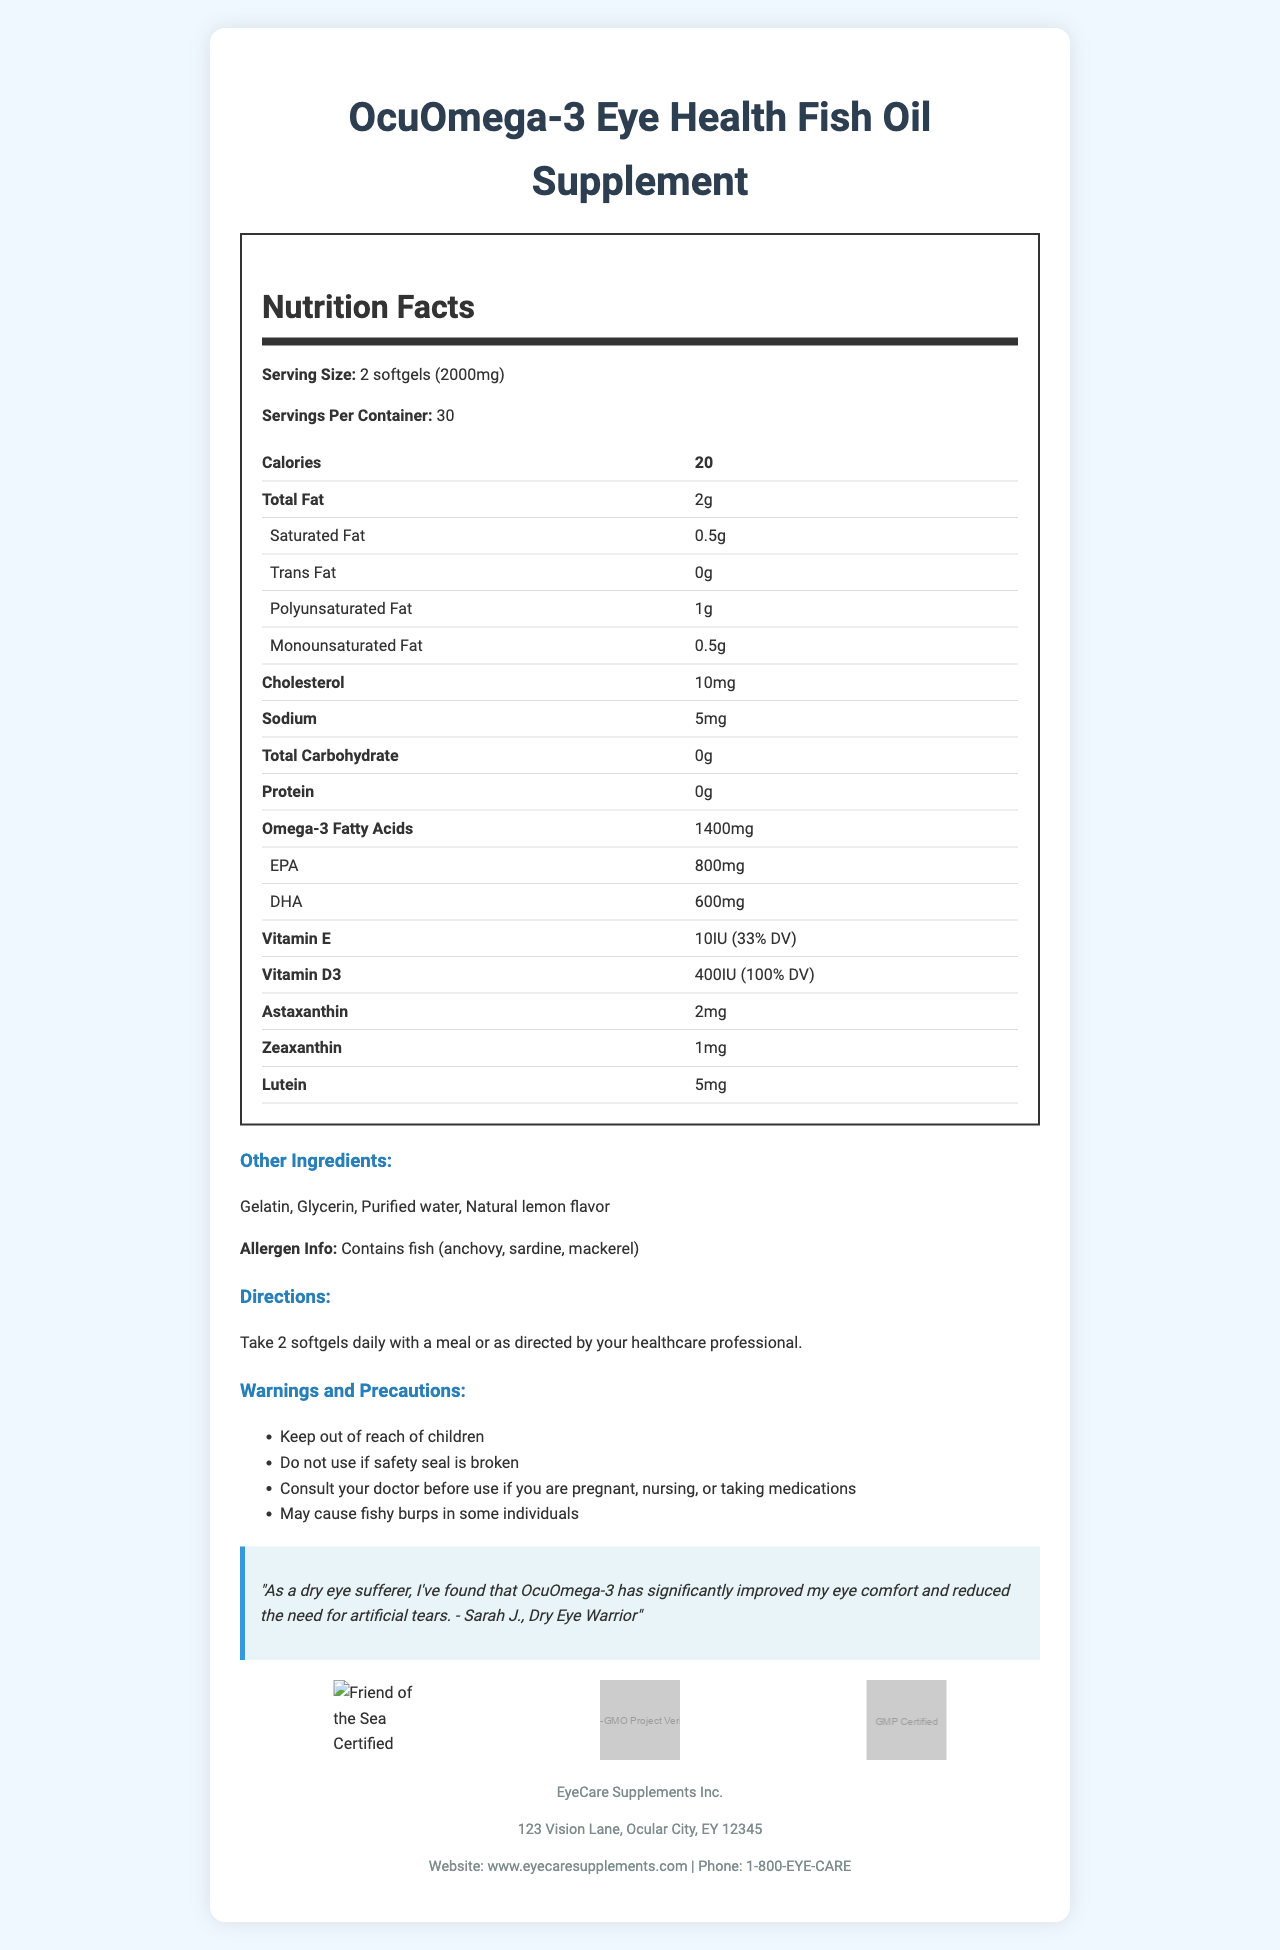what is the serving size for OcuOmega-3 Eye Health Fish Oil Supplement? The serving size information is provided at the beginning of the Nutrition Facts section.
Answer: 2 softgels (2000mg) what are the omega-3 fatty acid contents per serving? The amount of omega-3 fatty acids per serving is listed under the corresponding Nutrition Facts category.
Answer: 1400mg how many calories are there per serving? The calories per serving are prominently displayed in the Nutrition Facts section.
Answer: 20 What is the recommended daily dosage? The directions for use mention that you should take 2 softgels daily with a meal or as directed by a healthcare professional.
Answer: 2 softgels daily with a meal how much EPA and DHA are in each serving? The amounts of EPA and DHA per serving are listed under the Nutrition Facts for omega-3 fatty acids.
Answer: EPA: 800mg, DHA: 600mg what are the certifications associated with this product? The certifications are listed towards the bottom of the document with corresponding icons.
Answer: Friend of the Sea Certified, Non-GMO Project Verified, GMP Certified what should you do if the safety seal is broken? The document states in the Warnings and Precautions section to not use the product if the safety seal is broken.
Answer: Do not use what are the potential allergens in this supplement? The allergen information is listed in the Other Ingredients section.
Answer: Fish (anchovy, sardine, mackerel) which vitamins are included and in what quantities? The amounts and percentages of vitamins E and D3 are listed in the Nutrition Facts section.
Answer: Vitamin E: 10IU (33% DV), Vitamin D3: 400IU (100% DV) What is the primary benefit of this supplement as per the patient testimonial? The patient testimonial at the bottom of the document mentions these benefits.
Answer: Improved eye comfort and reduced need for artificial tears What fat components are listed and in what quantities? A. Total Fat: 2g, Trans Fat: 0g B. Total Fat: 2g, Saturated Fat: 1g C. Total Fat: 3g, Saturated Fat: 1g The Nutrition Facts section lists total fat as 2g and trans fat as 0g. The other listed categories are incorrect.
Answer: A. Total Fat: 2g, Trans Fat: 0g How many servings per container are there? i. 20 ii. 30 iii. 60 The number of servings per container is clearly listed under the Serving Information section.
Answer: ii. 30 Does this supplement contain any carbohydrates? The document mentions that the total carbohydrate content is 0g.
Answer: No Can the effectiveness of this supplement be evaluated solely based on the document? The document contains nutritional and ingredient information but lacks clinical trial data or scientific references to evaluate effectiveness.
Answer: No Describe the purpose and content of the document. The Nutrition Facts label is organized to provide comprehensive details about the supplement, including the amounts of various nutrients and ingredients. The document aims to present the health benefits, usage guidelines, and allergen information to potential users effectively.
Answer: The document provides detailed nutritional information, directions for use, warnings, and additional details about the OcuOmega-3 Eye Health Fish Oil Supplement. It highlights the omega-3 fatty acids, vitamins, and other beneficial compounds included in the supplement, along with manufacturer information and certifications. A patient testimonial about eye health improvement is also included. 